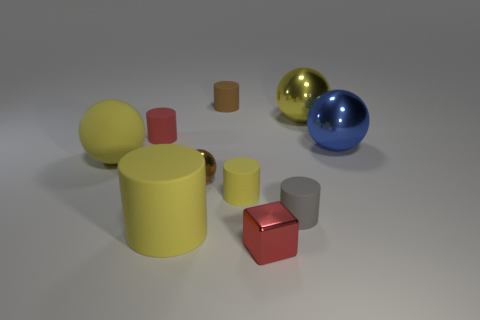There is a matte cylinder that is behind the large object that is behind the red matte object that is behind the small yellow matte cylinder; how big is it?
Your response must be concise. Small. There is a big ball left of the big thing in front of the matte object that is to the right of the tiny block; what is its material?
Your response must be concise. Rubber. Does the yellow metal object have the same shape as the large blue object?
Provide a short and direct response. Yes. How many brown objects are both in front of the big yellow metal ball and behind the small brown metallic thing?
Your response must be concise. 0. There is a ball that is to the left of the red object behind the small red cube; what is its color?
Ensure brevity in your answer.  Yellow. Are there an equal number of large yellow shiny objects that are behind the tiny yellow rubber cylinder and large rubber spheres?
Keep it short and to the point. Yes. There is a metal object behind the small red thing that is behind the tiny gray matte cylinder; how many big yellow matte cylinders are on the left side of it?
Offer a terse response. 1. What is the color of the large sphere behind the tiny red matte cylinder?
Your answer should be compact. Yellow. What is the thing that is behind the small red cylinder and in front of the small brown matte thing made of?
Keep it short and to the point. Metal. How many big metal objects are in front of the metallic object that is to the right of the big yellow metallic ball?
Make the answer very short. 0. 